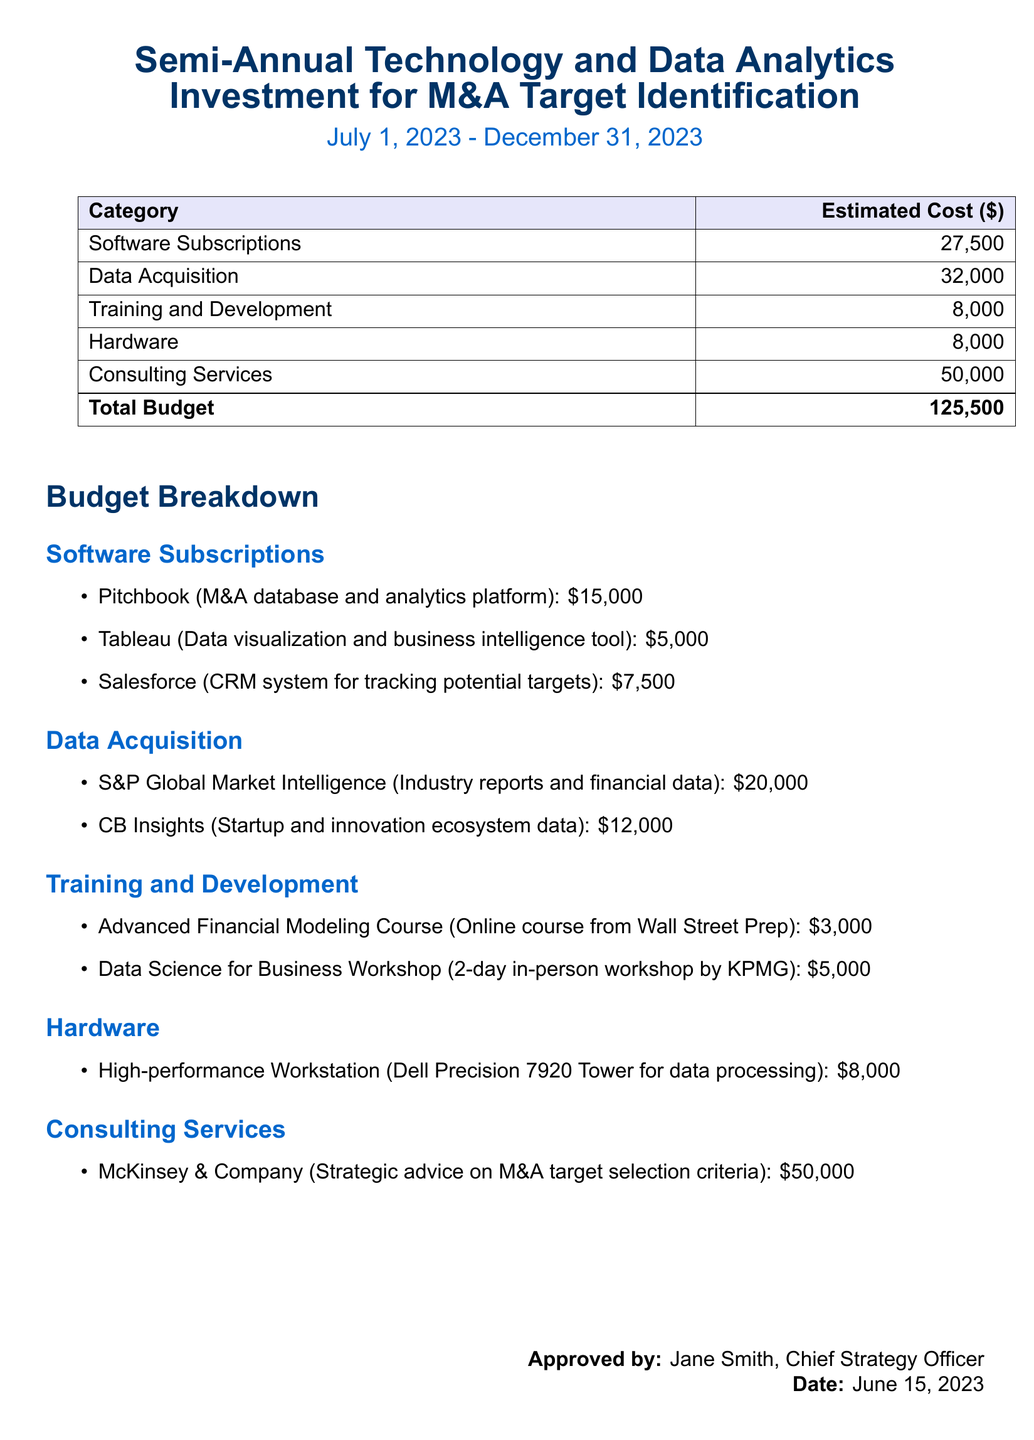What is the total budget for the semi-annual investment? The total budget is clearly listed in the document, summed up from all categories as provided.
Answer: 125,500 How much is allocated for consulting services? The expense for consulting services is detailed in the budget breakdown section.
Answer: 50,000 Who approved the budget? The document specifies the person who approved the budget at the end.
Answer: Jane Smith What is the cost of software subscription for Salesforce? The Salesforce subscription cost is included in the software subscriptions section.
Answer: 7,500 What is the estimated cost for data acquisition? Data acquisition expenses are summarized in the budget breakdown, showing the total.
Answer: 32,000 How many training workshops are listed in the budget? The number of workshops is mentioned specifically in the training and development section.
Answer: 1 What is the budget for hardware investments? The hardware expenses are detailed in the budget breakdown.
Answer: 8,000 What is the cost of the Advanced Financial Modeling Course? The specific cost of the course is listed in the training and development breakdown.
Answer: 3,000 Which company provides strategic advice on M&A target selection? The document mentions the consulting firm engaged for strategic advice in the budget breakdown.
Answer: McKinsey & Company 